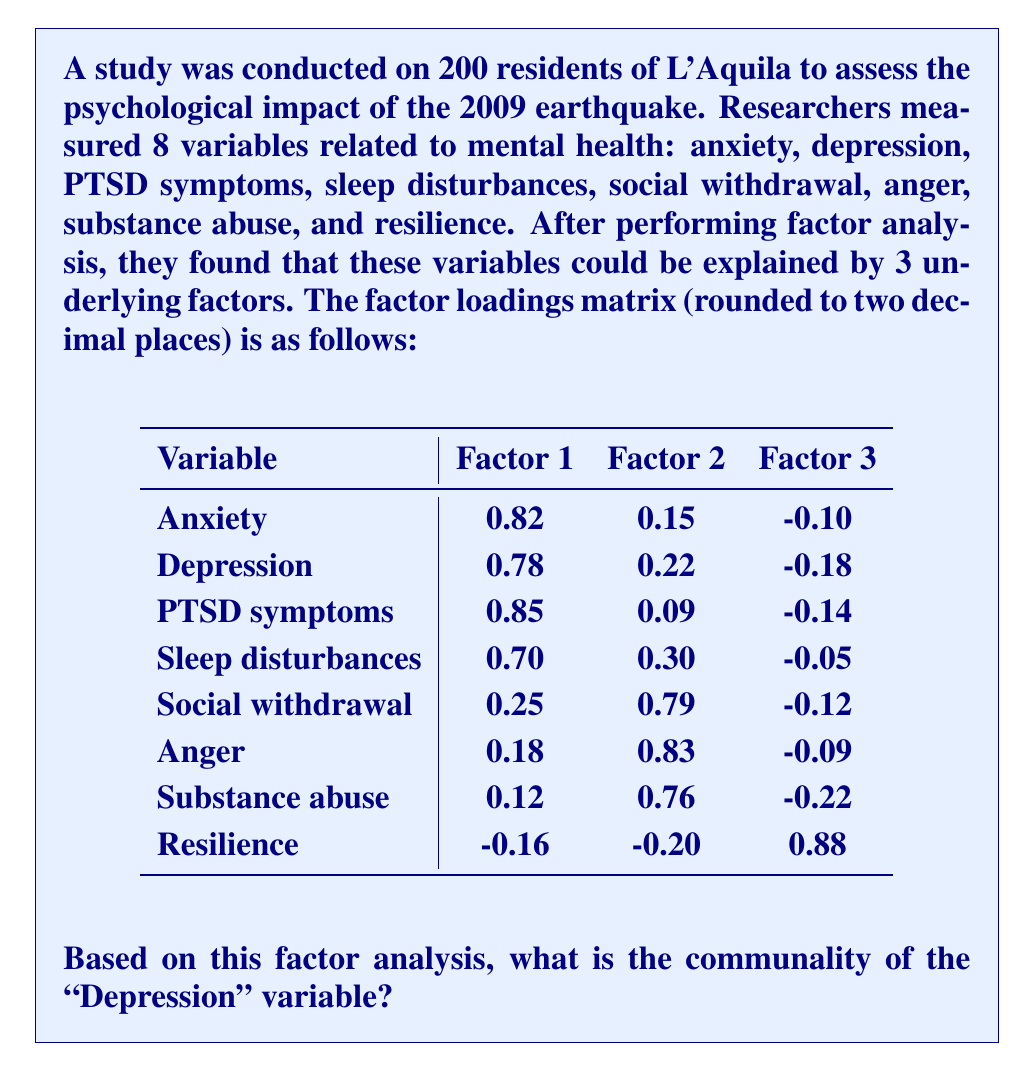Could you help me with this problem? To find the communality of the "Depression" variable, we need to follow these steps:

1) Communality represents the proportion of a variable's variance that is accounted for by the common factors. It is calculated as the sum of squared factor loadings for that variable across all factors.

2) For the "Depression" variable, we need to square each factor loading and then sum these squared values:

   Factor 1 loading: $0.78^2 = 0.6084$
   Factor 2 loading: $0.22^2 = 0.0484$
   Factor 3 loading: $(-0.18)^2 = 0.0324$

3) Sum these squared loadings:
   
   $0.6084 + 0.0484 + 0.0324 = 0.6892$

4) This sum represents the communality of the "Depression" variable.

5) Rounding to two decimal places: $0.6892 \approx 0.69$

Therefore, the communality of the "Depression" variable is approximately 0.69, meaning that about 69% of the variance in depression scores is explained by the three common factors identified in this factor analysis.
Answer: 0.69 